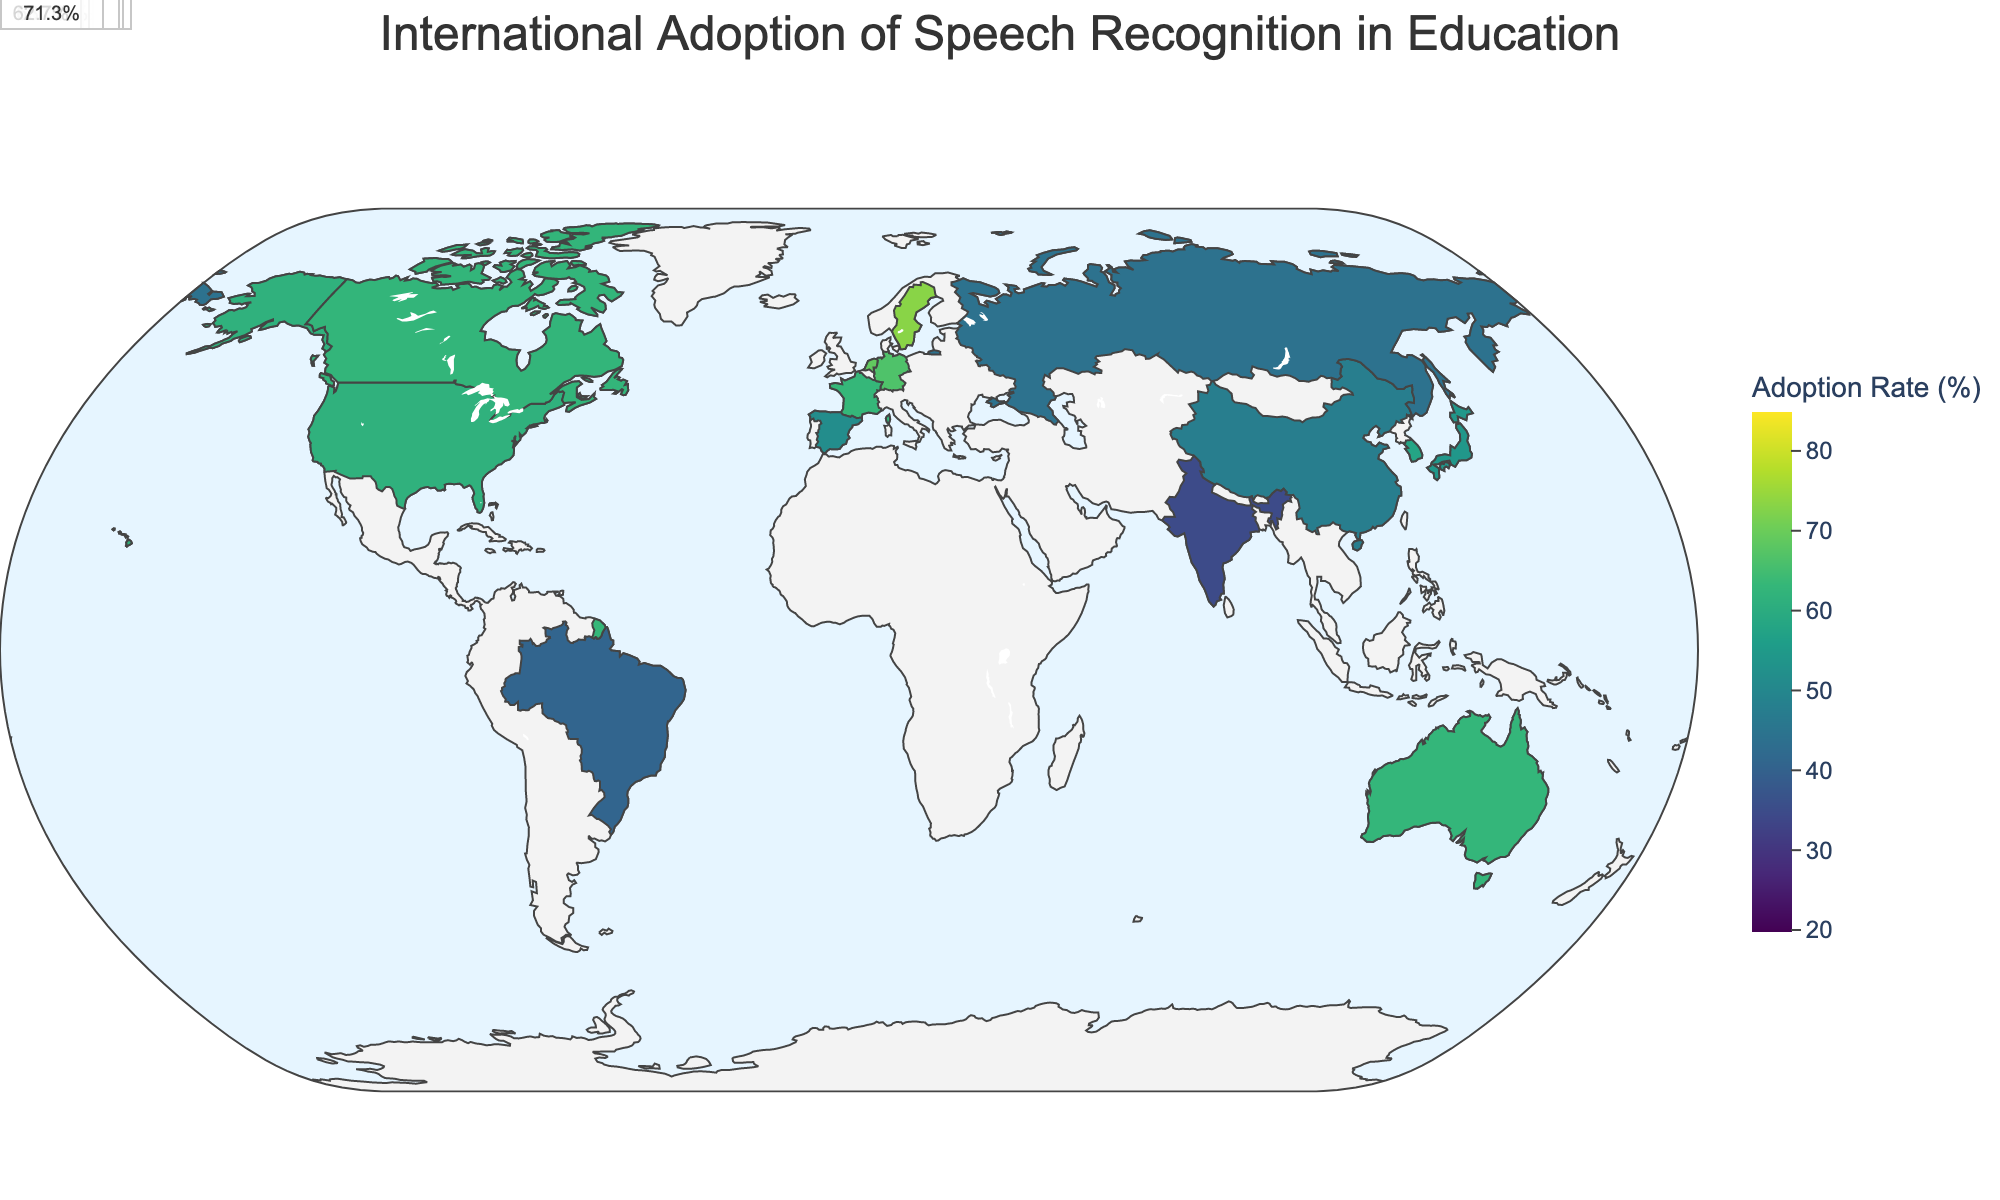What is the average adoption rate of speech recognition technology in educational institutions for Sweden? By looking at the annotation near Sweden, the average adoption rate is shown in percentage.
Answer: 73.3% Which country has the highest adoption rate of speech recognition technology in Primary education? Inspecting the figure, the country with the darkest shade in the primary education category is Sweden. Confirming this by hovering over Sweden shows the primary adoption rate.
Answer: Sweden Compare the adoption rates in Higher Education between Japan and Germany. Which country has a higher rate? Hovering over both countries shows the adoption rates in Higher Education. Comparing these, Germany has a rate of 80%, while Japan has 70%.
Answer: Germany What's the difference in the adoption rate of speech recognition technology between Primary and Higher Education in the United States? Looking at the adoption rates for Primary and Higher Education in the United States and subtracting them: 78% - 45% = 33%.
Answer: 33% Which country has a closer average adoption rate to 70%, Brazil or Spain? Examine the average adoption rates for Brazil and Spain. Brazil has 41%, and Spain has 51.67%. The difference for Spain is smaller (70% - 51.67% = 18.33%) compared to Brazil (70% - 41% = 29%).
Answer: Spain How does the adoption rate in Secondary education in India compare to that in Russia? By observing the adoption rates in Secondary education for both countries: India has 35%, and Russia has 45%. Thus, Russia has a higher rate of adoption.
Answer: Russia What is the range of adoption rates across all countries in Higher Education? Identify the highest and lowest values by looking at the hover information on each country. The highest is Sweden at 85%, and the lowest is India at 50%. The range is 85% - 50% = 35%.
Answer: 35% Which country has the second highest average adoption rate after Sweden? Sorting countries by average adoption rate, after Sweden (73.3%), the next highest rate is Netherlands with 69%.
Answer: Netherlands What is the overall trend in adoption rate as the education level increases in China? Observing the percentages in China across the education levels: Primary (30%), Secondary (48%), Higher Education (65%), the trend shows an increase in adoption rate as the education level rises.
Answer: Increases Which language focus has the highest average adoption rate across all levels of education? Average the adoption rates for countries grouped by language focus, finding Swedish-speaking Sweden (73.3%) has the highest.
Answer: Swedish 